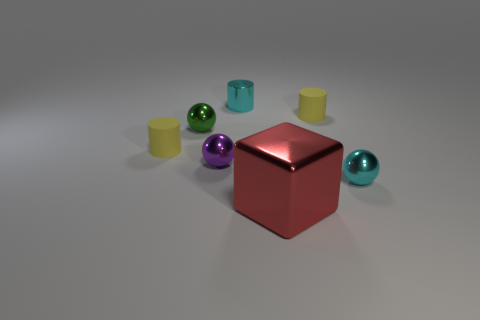Add 3 red shiny blocks. How many objects exist? 10 Subtract all cylinders. How many objects are left? 4 Subtract all tiny cyan metal objects. Subtract all green things. How many objects are left? 4 Add 4 small yellow cylinders. How many small yellow cylinders are left? 6 Add 1 cyan balls. How many cyan balls exist? 2 Subtract 0 gray cylinders. How many objects are left? 7 